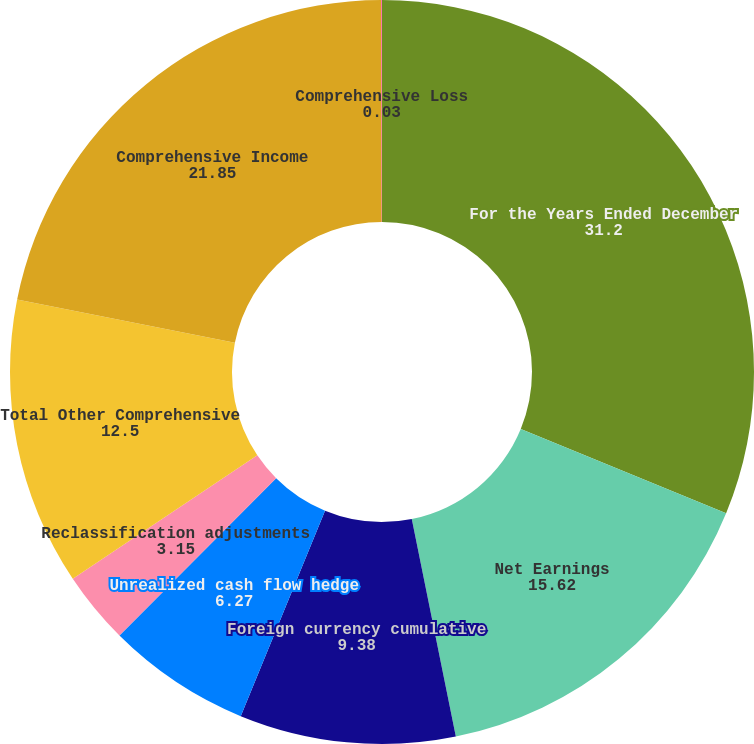Convert chart. <chart><loc_0><loc_0><loc_500><loc_500><pie_chart><fcel>For the Years Ended December<fcel>Net Earnings<fcel>Foreign currency cumulative<fcel>Unrealized cash flow hedge<fcel>Reclassification adjustments<fcel>Total Other Comprehensive<fcel>Comprehensive Income<fcel>Comprehensive Loss<nl><fcel>31.2%<fcel>15.62%<fcel>9.38%<fcel>6.27%<fcel>3.15%<fcel>12.5%<fcel>21.85%<fcel>0.03%<nl></chart> 